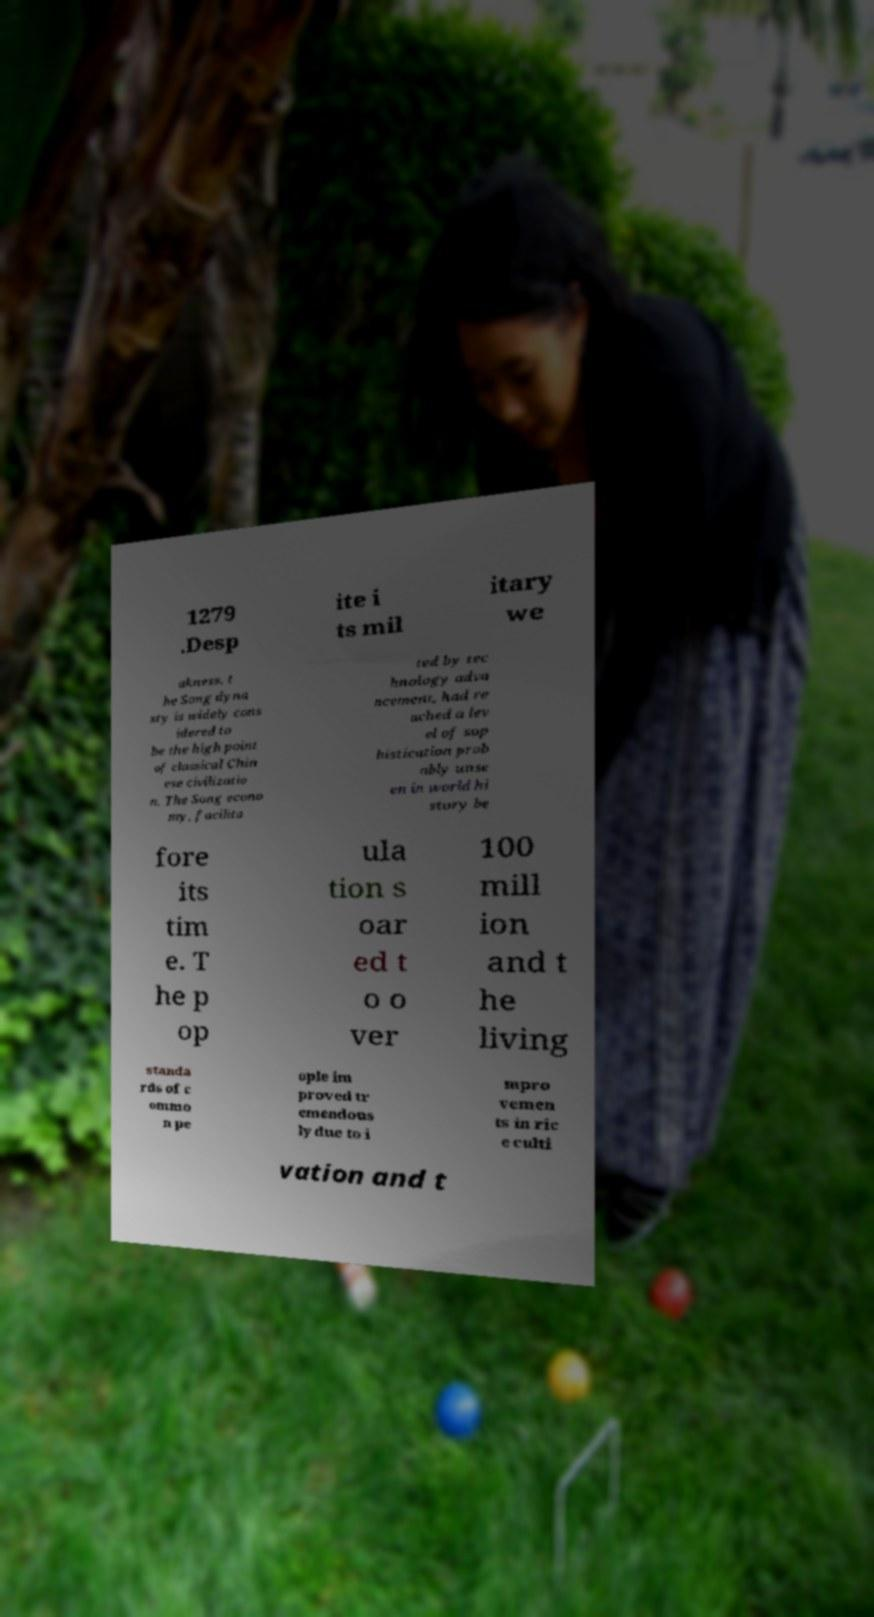Please read and relay the text visible in this image. What does it say? 1279 .Desp ite i ts mil itary we akness, t he Song dyna sty is widely cons idered to be the high point of classical Chin ese civilizatio n. The Song econo my, facilita ted by tec hnology adva ncement, had re ached a lev el of sop histication prob ably unse en in world hi story be fore its tim e. T he p op ula tion s oar ed t o o ver 100 mill ion and t he living standa rds of c ommo n pe ople im proved tr emendous ly due to i mpro vemen ts in ric e culti vation and t 